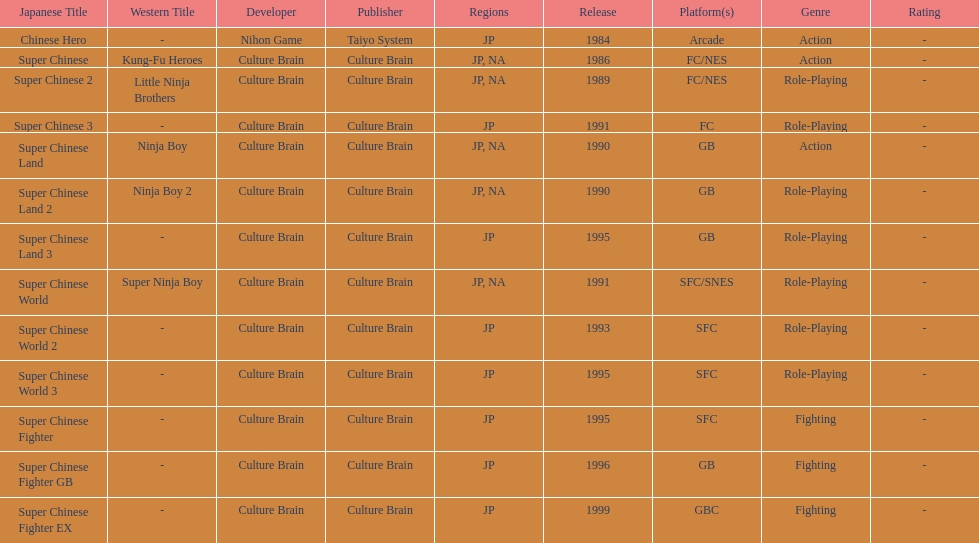What are the total of super chinese games released? 13. 